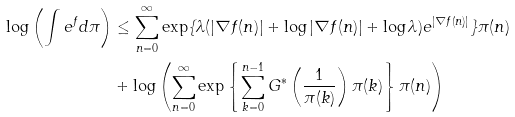<formula> <loc_0><loc_0><loc_500><loc_500>\log \left ( \int e ^ { f } d \pi \right ) & \leq \sum _ { n = 0 } ^ { \infty } \exp \{ \lambda ( | \nabla f ( n ) | + \log | \nabla f ( n ) | + \log \lambda ) e ^ { | \nabla f ( n ) | } \} \pi ( n ) \\ & + \log \left ( \sum _ { n = 0 } ^ { \infty } \exp \left \{ \sum _ { k = 0 } ^ { n - 1 } G ^ { * } \left ( \frac { 1 } { \pi ( k ) } \right ) \pi ( k ) \right \} \pi ( n ) \right )</formula> 